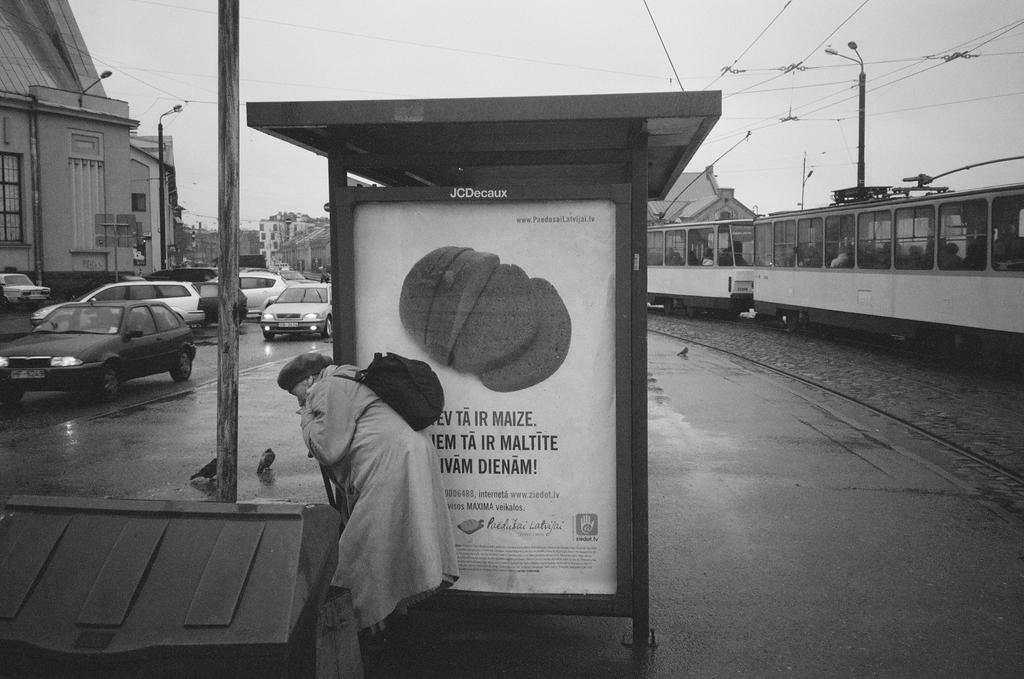Could you give a brief overview of what you see in this image? This image is clicked on the road. To the left there are vehicles moving on the road. To the right there is a train moving on the railway track. In the center there is a person standing. Behind him there is a board. There is text on the board. In the background there are buildings and poles. At the top there is the sky. 